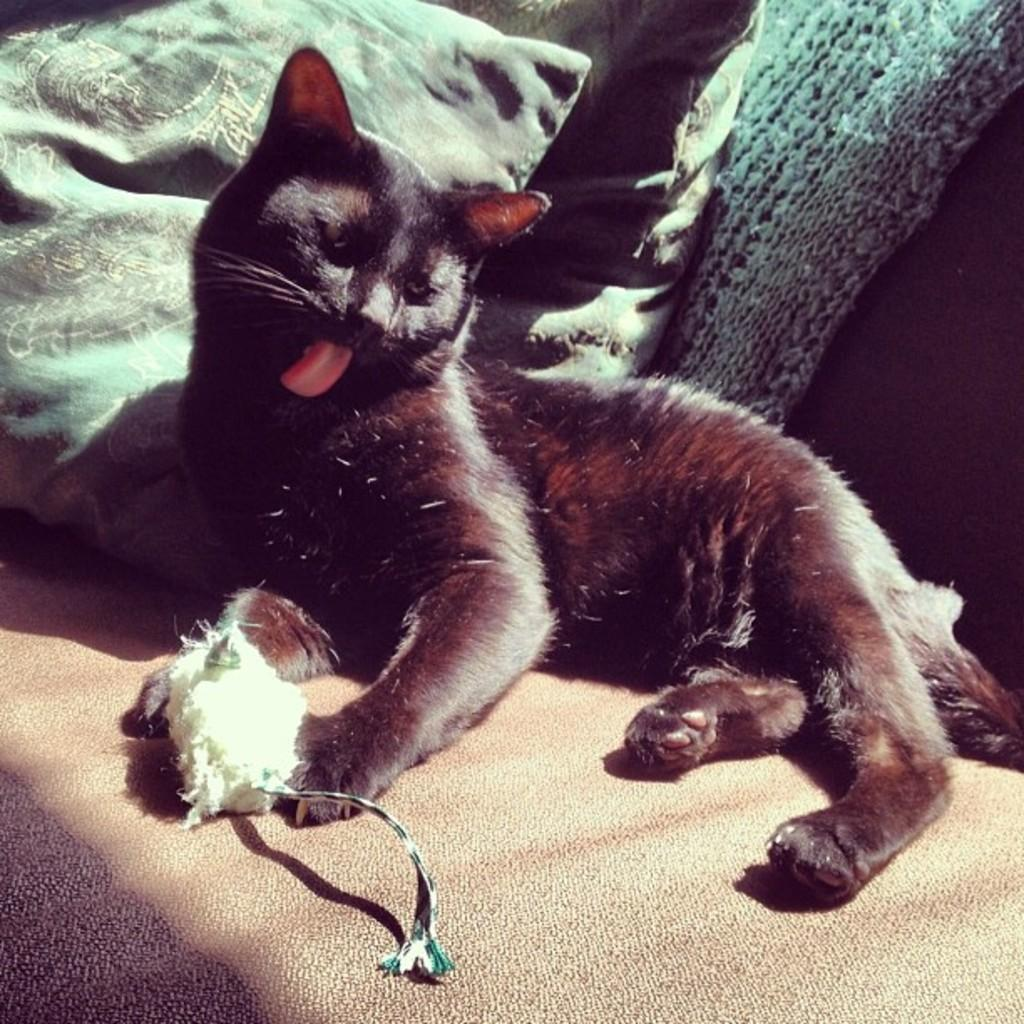What is the main subject in the center of the image? There is a cat in the center of the image. What is the cat lying on? The cat is lying on a sofa. What type of furniture accessory is present on the sofa? There are cushions placed on the sofa. How does the cat use the yoke in the image? There is no yoke present in the image; it only features a cat lying on a sofa with cushions. What type of bag is the cat holding in the image? There is no bag present in the image; it only features a cat lying on a sofa with cushions. 